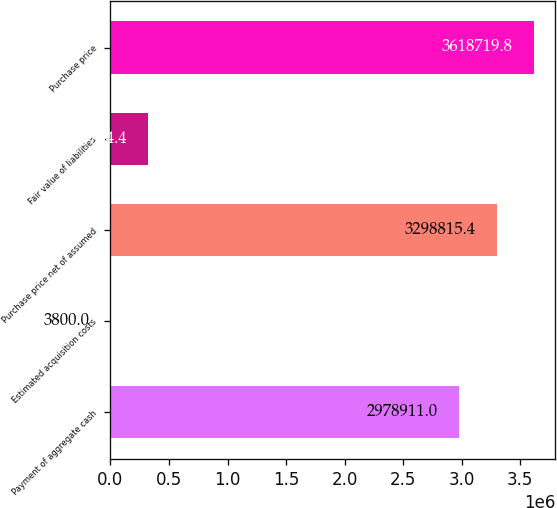<chart> <loc_0><loc_0><loc_500><loc_500><bar_chart><fcel>Payment of aggregate cash<fcel>Estimated acquisition costs<fcel>Purchase price net of assumed<fcel>Fair value of liabilities<fcel>Purchase price<nl><fcel>2.97891e+06<fcel>3800<fcel>3.29882e+06<fcel>323704<fcel>3.61872e+06<nl></chart> 